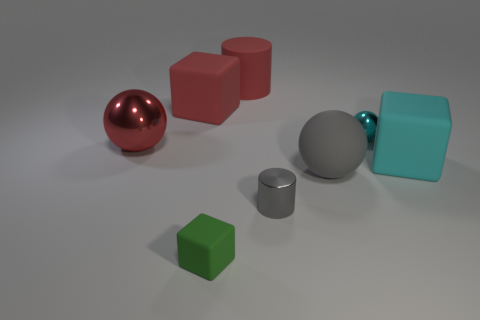Add 1 big red blocks. How many objects exist? 9 Subtract all cylinders. How many objects are left? 6 Subtract 0 brown balls. How many objects are left? 8 Subtract all large blue rubber objects. Subtract all cyan spheres. How many objects are left? 7 Add 8 green blocks. How many green blocks are left? 9 Add 3 big red matte spheres. How many big red matte spheres exist? 3 